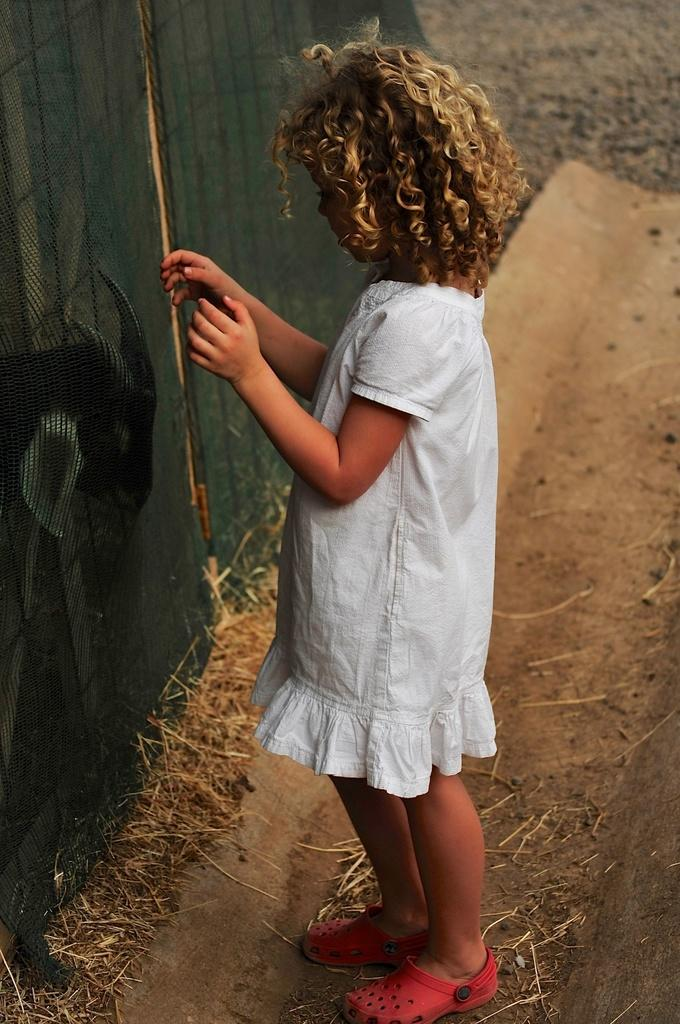Who is the main subject in the image? There is a girl in the image. What is the girl doing in the image? The girl is standing. What is the girl wearing on her feet? The girl is wearing footwear. What type of terrain is visible in the image? There is dry grass in the image. What object can be seen in the image that might be used for catching or holding things? There is a net in the image. What animal is present in the image? There is a goat in the image. What type of wire can be seen connecting the girl's heart to the goat in the image? There is no wire connecting the girl's heart to the goat in the image. 